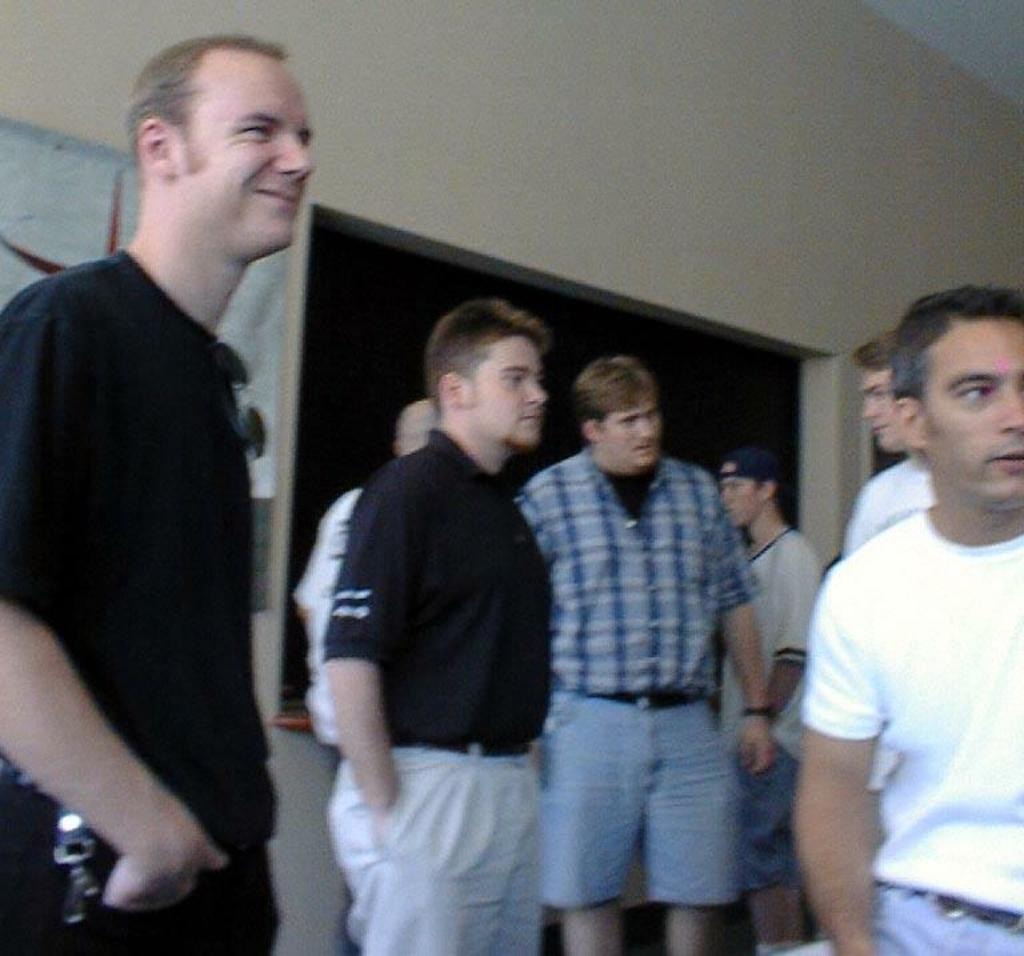What is happening in the image? There are people standing in the image. What can be seen in the background of the image? There is a wall and a board visible in the background of the image. What is the tax rate for the people in the image? There is no information about tax rates in the image, as it only shows people standing and a wall and board in the background. 